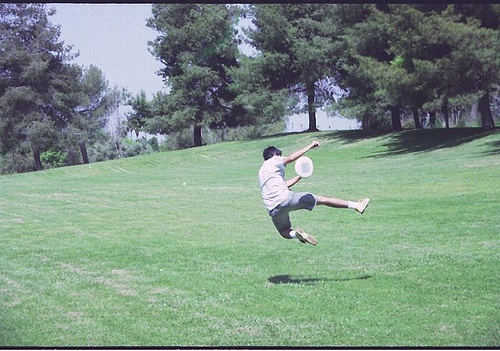Describe the objects in this image and their specific colors. I can see people in black, lavender, darkgray, gray, and lightgreen tones and frisbee in black, lavender, darkgray, and lightgray tones in this image. 